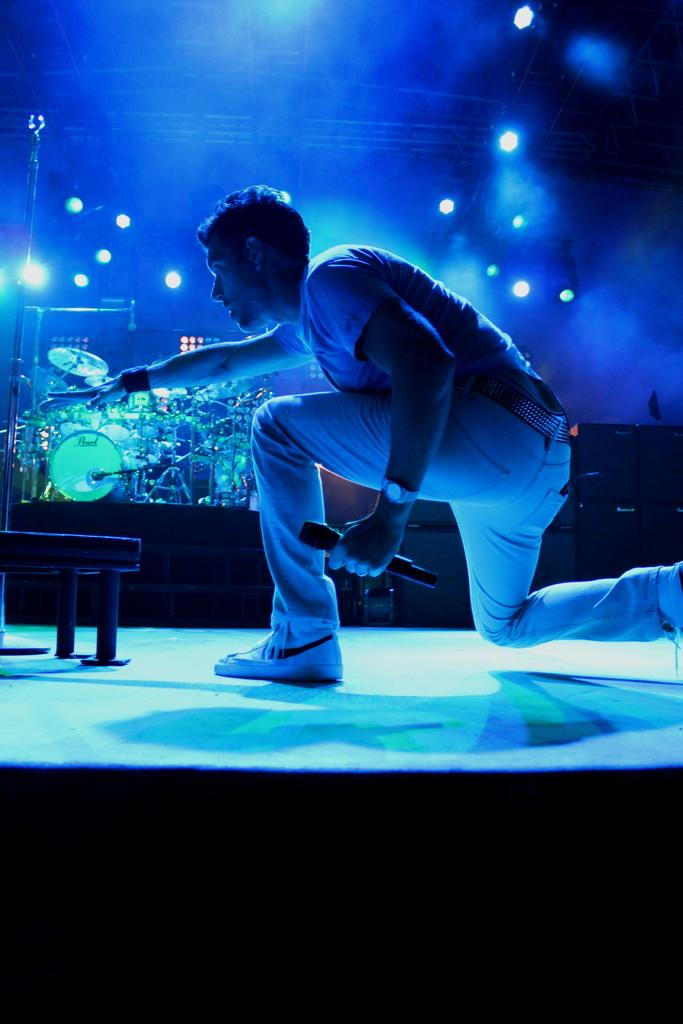Who is the main subject in the image? There is a man in the image. What is the man holding in the image? The man is holding a microphone. What can be seen in the background of the image? There are musical instruments and lights in the background of the image. Where is the kitten playing with a hook in the image? There is no kitten or hook present in the image. 